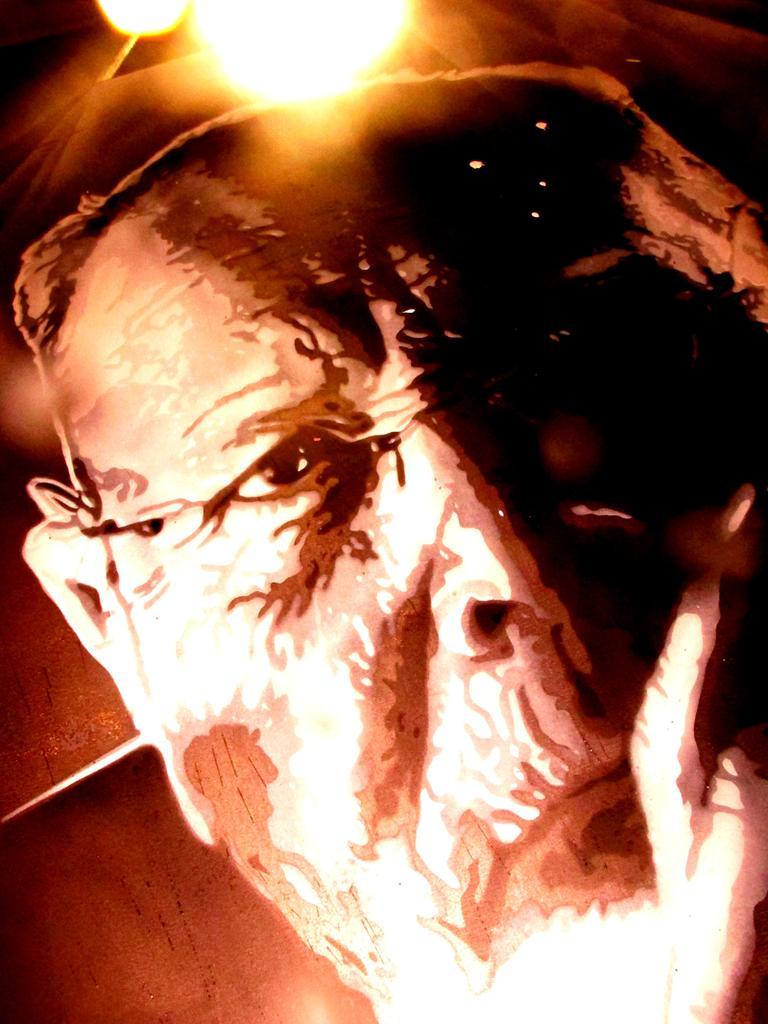How would you summarize this image in a sentence or two? In this image I can see a person's face which is brown, cream and black in color and to the top of the image I can see a light. In the background I can see the brown colored surface. 